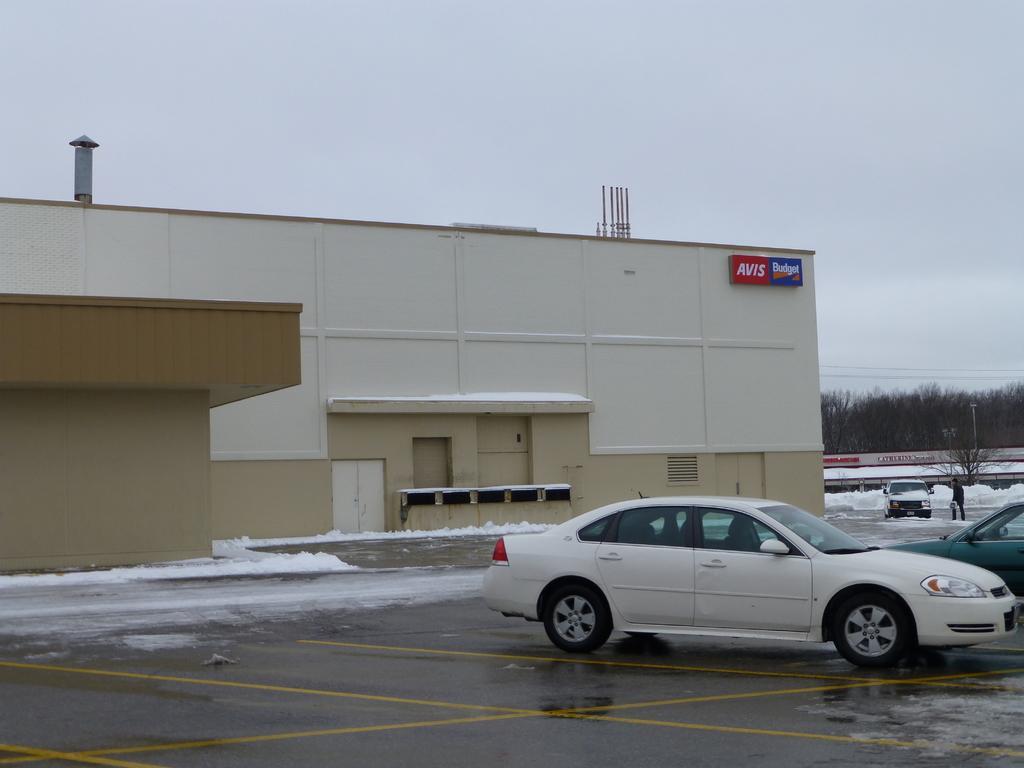How would you summarize this image in a sentence or two? This picture is clicked outside. On the right we can see the group of vehicles and we can see a person seems to be standing on the ground. On the left we can see the building. In the background we can see the sky, trees, snow and some other objects. 